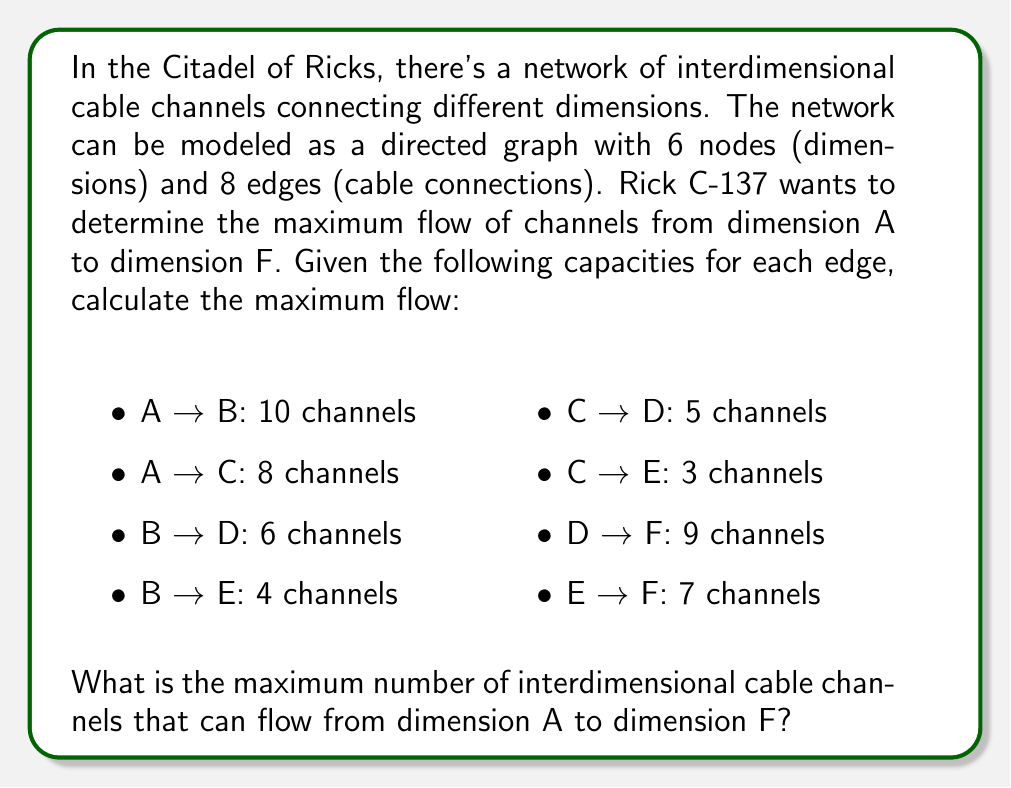Help me with this question. To solve this problem, we'll use the Ford-Fulkerson algorithm, which is perfect for determining the maximum flow in a network. Let's follow these steps:

1. Initialize the flow to 0 for all edges.

2. Find an augmenting path from A to F using depth-first search (DFS). We'll use residual capacities to find these paths.

3. For each augmenting path found, determine the minimum residual capacity along the path and add this flow to the total.

4. Repeat steps 2-3 until no more augmenting paths can be found.

Let's go through the iterations:

Iteration 1:
Path: A → B → D → F
Minimum capacity: min(10, 6, 9) = 6
Flow after iteration: 6

Iteration 2:
Path: A → C → D → F
Minimum capacity: min(8, 5, 3) = 3
Flow after iteration: 6 + 3 = 9

Iteration 3:
Path: A → B → E → F
Minimum capacity: min(4, 4, 7) = 4
Flow after iteration: 9 + 4 = 13

Iteration 4:
Path: A → C → E → F
Minimum capacity: min(5, 3, 3) = 3
Flow after iteration: 13 + 3 = 16

No more augmenting paths can be found, so the algorithm terminates.

The maximum flow is therefore 16 channels.

This result can be verified by looking at the min-cut of the graph, which separates nodes {A, B, C, D, E} from {F}. The capacity of this cut is indeed 16 (9 from D→F and 7 from E→F), which equals our computed maximum flow.
Answer: The maximum number of interdimensional cable channels that can flow from dimension A to dimension F is 16. 